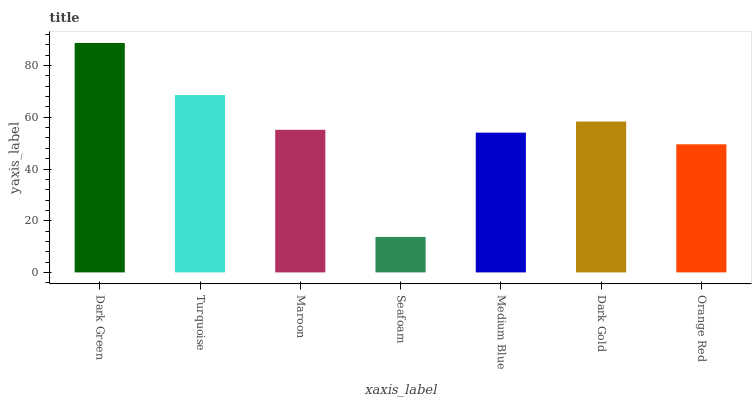Is Seafoam the minimum?
Answer yes or no. Yes. Is Dark Green the maximum?
Answer yes or no. Yes. Is Turquoise the minimum?
Answer yes or no. No. Is Turquoise the maximum?
Answer yes or no. No. Is Dark Green greater than Turquoise?
Answer yes or no. Yes. Is Turquoise less than Dark Green?
Answer yes or no. Yes. Is Turquoise greater than Dark Green?
Answer yes or no. No. Is Dark Green less than Turquoise?
Answer yes or no. No. Is Maroon the high median?
Answer yes or no. Yes. Is Maroon the low median?
Answer yes or no. Yes. Is Dark Green the high median?
Answer yes or no. No. Is Orange Red the low median?
Answer yes or no. No. 